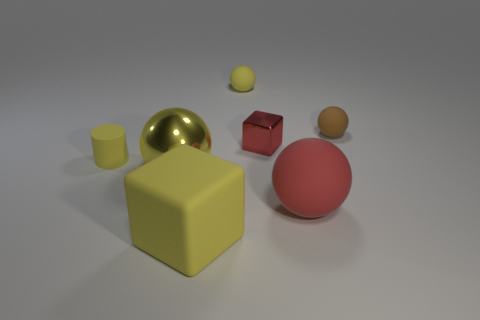How many other objects are there of the same material as the small yellow sphere?
Provide a short and direct response. 4. There is a yellow matte thing in front of the large yellow sphere; is it the same shape as the shiny object right of the big cube?
Make the answer very short. Yes. The red rubber object that is the same size as the yellow shiny sphere is what shape?
Your answer should be compact. Sphere. The tiny cylinder that is made of the same material as the small brown sphere is what color?
Your response must be concise. Yellow. Do the red rubber object and the big yellow metallic thing that is in front of the yellow matte ball have the same shape?
Keep it short and to the point. Yes. What material is the big sphere that is the same color as the matte block?
Provide a succinct answer. Metal. There is a block that is the same size as the brown matte thing; what is its material?
Offer a terse response. Metal. Are there any big balls that have the same color as the small metallic cube?
Provide a succinct answer. Yes. What is the shape of the small matte thing that is both left of the small cube and on the right side of the large block?
Offer a very short reply. Sphere. How many big yellow spheres have the same material as the small brown ball?
Your answer should be very brief. 0. 